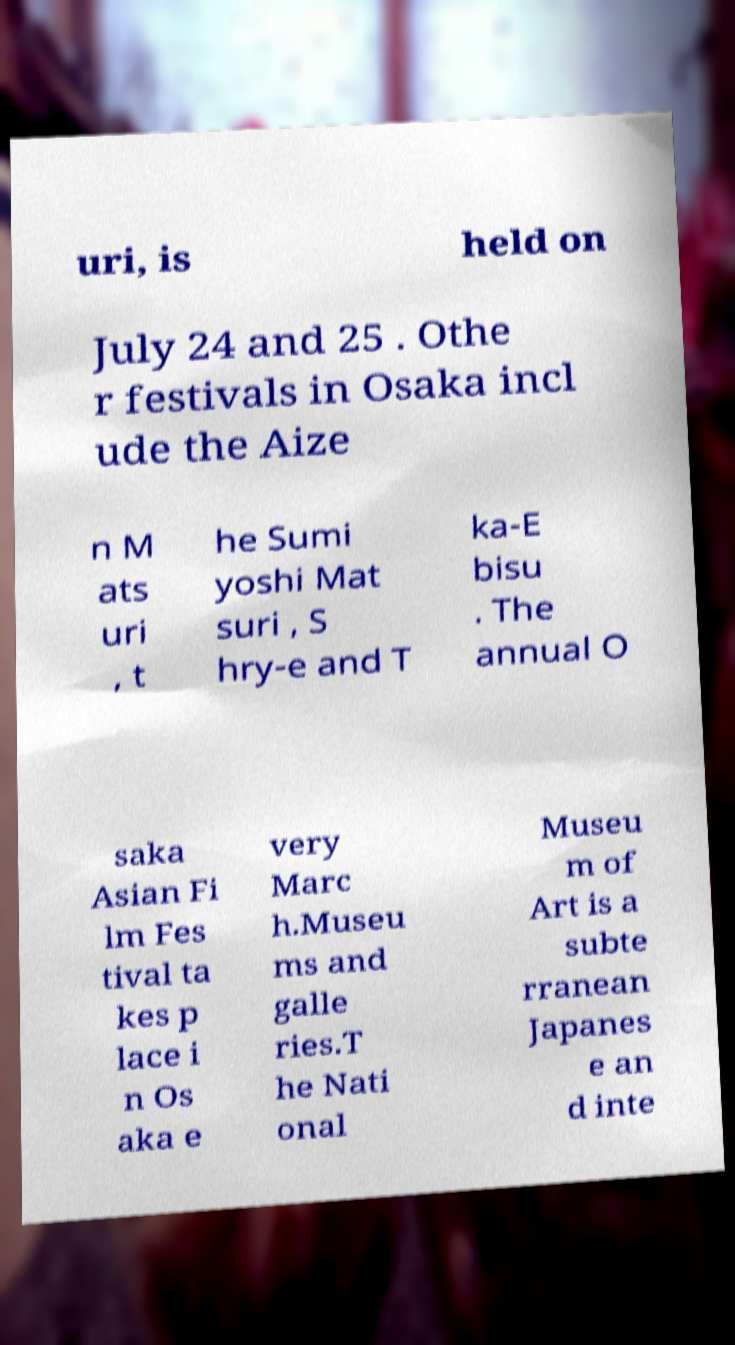Could you assist in decoding the text presented in this image and type it out clearly? uri, is held on July 24 and 25 . Othe r festivals in Osaka incl ude the Aize n M ats uri , t he Sumi yoshi Mat suri , S hry-e and T ka-E bisu . The annual O saka Asian Fi lm Fes tival ta kes p lace i n Os aka e very Marc h.Museu ms and galle ries.T he Nati onal Museu m of Art is a subte rranean Japanes e an d inte 